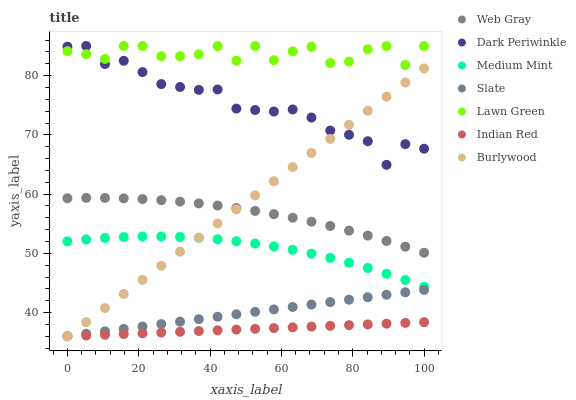Does Indian Red have the minimum area under the curve?
Answer yes or no. Yes. Does Lawn Green have the maximum area under the curve?
Answer yes or no. Yes. Does Web Gray have the minimum area under the curve?
Answer yes or no. No. Does Web Gray have the maximum area under the curve?
Answer yes or no. No. Is Slate the smoothest?
Answer yes or no. Yes. Is Lawn Green the roughest?
Answer yes or no. Yes. Is Web Gray the smoothest?
Answer yes or no. No. Is Web Gray the roughest?
Answer yes or no. No. Does Burlywood have the lowest value?
Answer yes or no. Yes. Does Web Gray have the lowest value?
Answer yes or no. No. Does Dark Periwinkle have the highest value?
Answer yes or no. Yes. Does Web Gray have the highest value?
Answer yes or no. No. Is Web Gray less than Dark Periwinkle?
Answer yes or no. Yes. Is Web Gray greater than Slate?
Answer yes or no. Yes. Does Slate intersect Indian Red?
Answer yes or no. Yes. Is Slate less than Indian Red?
Answer yes or no. No. Is Slate greater than Indian Red?
Answer yes or no. No. Does Web Gray intersect Dark Periwinkle?
Answer yes or no. No. 